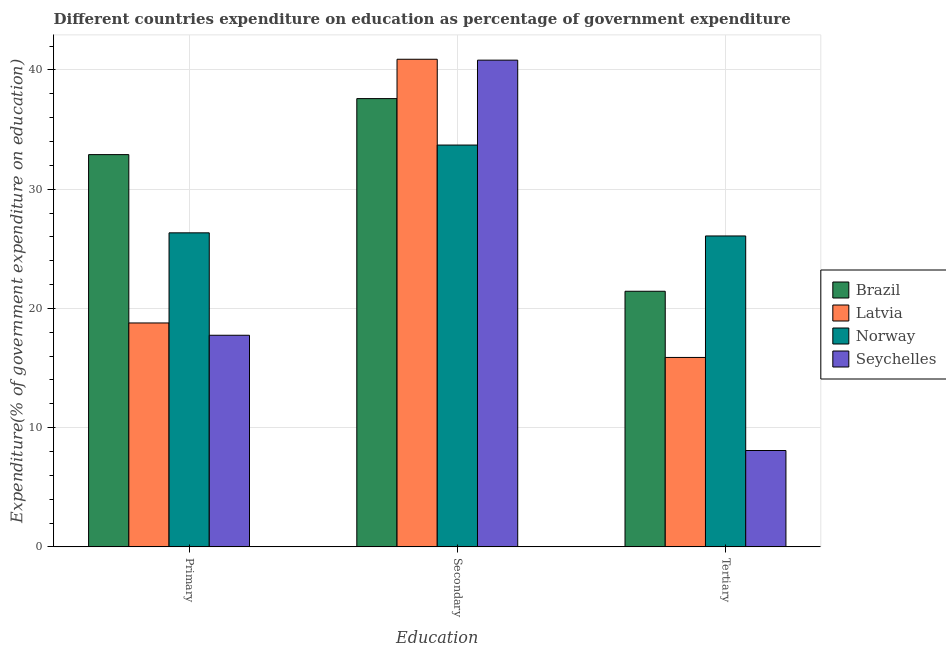How many different coloured bars are there?
Keep it short and to the point. 4. How many groups of bars are there?
Offer a very short reply. 3. Are the number of bars per tick equal to the number of legend labels?
Your response must be concise. Yes. Are the number of bars on each tick of the X-axis equal?
Give a very brief answer. Yes. How many bars are there on the 1st tick from the left?
Ensure brevity in your answer.  4. What is the label of the 3rd group of bars from the left?
Ensure brevity in your answer.  Tertiary. What is the expenditure on secondary education in Seychelles?
Provide a short and direct response. 40.82. Across all countries, what is the maximum expenditure on primary education?
Your response must be concise. 32.9. Across all countries, what is the minimum expenditure on tertiary education?
Make the answer very short. 8.08. In which country was the expenditure on tertiary education maximum?
Your answer should be compact. Norway. In which country was the expenditure on secondary education minimum?
Offer a terse response. Norway. What is the total expenditure on secondary education in the graph?
Offer a terse response. 153.01. What is the difference between the expenditure on secondary education in Seychelles and that in Norway?
Your response must be concise. 7.12. What is the difference between the expenditure on tertiary education in Norway and the expenditure on primary education in Seychelles?
Your response must be concise. 8.33. What is the average expenditure on secondary education per country?
Ensure brevity in your answer.  38.25. What is the difference between the expenditure on secondary education and expenditure on primary education in Latvia?
Make the answer very short. 22.12. In how many countries, is the expenditure on tertiary education greater than 16 %?
Provide a short and direct response. 2. What is the ratio of the expenditure on tertiary education in Brazil to that in Latvia?
Ensure brevity in your answer.  1.35. Is the expenditure on secondary education in Norway less than that in Seychelles?
Offer a terse response. Yes. What is the difference between the highest and the second highest expenditure on secondary education?
Provide a succinct answer. 0.07. What is the difference between the highest and the lowest expenditure on tertiary education?
Offer a terse response. 17.99. Is the sum of the expenditure on primary education in Seychelles and Brazil greater than the maximum expenditure on secondary education across all countries?
Your answer should be compact. Yes. What does the 4th bar from the left in Primary represents?
Provide a succinct answer. Seychelles. What does the 1st bar from the right in Tertiary represents?
Your answer should be compact. Seychelles. Is it the case that in every country, the sum of the expenditure on primary education and expenditure on secondary education is greater than the expenditure on tertiary education?
Provide a short and direct response. Yes. What is the difference between two consecutive major ticks on the Y-axis?
Offer a terse response. 10. Where does the legend appear in the graph?
Offer a very short reply. Center right. What is the title of the graph?
Keep it short and to the point. Different countries expenditure on education as percentage of government expenditure. Does "Niger" appear as one of the legend labels in the graph?
Give a very brief answer. No. What is the label or title of the X-axis?
Keep it short and to the point. Education. What is the label or title of the Y-axis?
Keep it short and to the point. Expenditure(% of government expenditure on education). What is the Expenditure(% of government expenditure on education) in Brazil in Primary?
Keep it short and to the point. 32.9. What is the Expenditure(% of government expenditure on education) of Latvia in Primary?
Make the answer very short. 18.78. What is the Expenditure(% of government expenditure on education) in Norway in Primary?
Your answer should be very brief. 26.34. What is the Expenditure(% of government expenditure on education) of Seychelles in Primary?
Your answer should be very brief. 17.75. What is the Expenditure(% of government expenditure on education) in Brazil in Secondary?
Offer a terse response. 37.6. What is the Expenditure(% of government expenditure on education) of Latvia in Secondary?
Ensure brevity in your answer.  40.9. What is the Expenditure(% of government expenditure on education) of Norway in Secondary?
Offer a very short reply. 33.7. What is the Expenditure(% of government expenditure on education) in Seychelles in Secondary?
Keep it short and to the point. 40.82. What is the Expenditure(% of government expenditure on education) in Brazil in Tertiary?
Offer a terse response. 21.44. What is the Expenditure(% of government expenditure on education) in Latvia in Tertiary?
Offer a very short reply. 15.89. What is the Expenditure(% of government expenditure on education) of Norway in Tertiary?
Provide a succinct answer. 26.07. What is the Expenditure(% of government expenditure on education) in Seychelles in Tertiary?
Offer a very short reply. 8.08. Across all Education, what is the maximum Expenditure(% of government expenditure on education) of Brazil?
Provide a short and direct response. 37.6. Across all Education, what is the maximum Expenditure(% of government expenditure on education) of Latvia?
Give a very brief answer. 40.9. Across all Education, what is the maximum Expenditure(% of government expenditure on education) of Norway?
Your answer should be very brief. 33.7. Across all Education, what is the maximum Expenditure(% of government expenditure on education) in Seychelles?
Offer a very short reply. 40.82. Across all Education, what is the minimum Expenditure(% of government expenditure on education) of Brazil?
Offer a terse response. 21.44. Across all Education, what is the minimum Expenditure(% of government expenditure on education) of Latvia?
Your response must be concise. 15.89. Across all Education, what is the minimum Expenditure(% of government expenditure on education) of Norway?
Offer a very short reply. 26.07. Across all Education, what is the minimum Expenditure(% of government expenditure on education) of Seychelles?
Provide a short and direct response. 8.08. What is the total Expenditure(% of government expenditure on education) of Brazil in the graph?
Provide a succinct answer. 91.93. What is the total Expenditure(% of government expenditure on education) of Latvia in the graph?
Ensure brevity in your answer.  75.56. What is the total Expenditure(% of government expenditure on education) in Norway in the graph?
Provide a succinct answer. 86.11. What is the total Expenditure(% of government expenditure on education) of Seychelles in the graph?
Your answer should be compact. 66.65. What is the difference between the Expenditure(% of government expenditure on education) in Brazil in Primary and that in Secondary?
Your response must be concise. -4.7. What is the difference between the Expenditure(% of government expenditure on education) of Latvia in Primary and that in Secondary?
Your response must be concise. -22.12. What is the difference between the Expenditure(% of government expenditure on education) of Norway in Primary and that in Secondary?
Provide a short and direct response. -7.36. What is the difference between the Expenditure(% of government expenditure on education) of Seychelles in Primary and that in Secondary?
Ensure brevity in your answer.  -23.07. What is the difference between the Expenditure(% of government expenditure on education) in Brazil in Primary and that in Tertiary?
Offer a very short reply. 11.46. What is the difference between the Expenditure(% of government expenditure on education) in Latvia in Primary and that in Tertiary?
Your answer should be very brief. 2.89. What is the difference between the Expenditure(% of government expenditure on education) in Norway in Primary and that in Tertiary?
Give a very brief answer. 0.26. What is the difference between the Expenditure(% of government expenditure on education) of Seychelles in Primary and that in Tertiary?
Your answer should be compact. 9.67. What is the difference between the Expenditure(% of government expenditure on education) in Brazil in Secondary and that in Tertiary?
Make the answer very short. 16.16. What is the difference between the Expenditure(% of government expenditure on education) of Latvia in Secondary and that in Tertiary?
Ensure brevity in your answer.  25.01. What is the difference between the Expenditure(% of government expenditure on education) of Norway in Secondary and that in Tertiary?
Your answer should be very brief. 7.63. What is the difference between the Expenditure(% of government expenditure on education) of Seychelles in Secondary and that in Tertiary?
Your response must be concise. 32.74. What is the difference between the Expenditure(% of government expenditure on education) of Brazil in Primary and the Expenditure(% of government expenditure on education) of Latvia in Secondary?
Ensure brevity in your answer.  -8. What is the difference between the Expenditure(% of government expenditure on education) of Brazil in Primary and the Expenditure(% of government expenditure on education) of Norway in Secondary?
Provide a short and direct response. -0.8. What is the difference between the Expenditure(% of government expenditure on education) in Brazil in Primary and the Expenditure(% of government expenditure on education) in Seychelles in Secondary?
Provide a succinct answer. -7.92. What is the difference between the Expenditure(% of government expenditure on education) of Latvia in Primary and the Expenditure(% of government expenditure on education) of Norway in Secondary?
Make the answer very short. -14.92. What is the difference between the Expenditure(% of government expenditure on education) in Latvia in Primary and the Expenditure(% of government expenditure on education) in Seychelles in Secondary?
Keep it short and to the point. -22.04. What is the difference between the Expenditure(% of government expenditure on education) of Norway in Primary and the Expenditure(% of government expenditure on education) of Seychelles in Secondary?
Provide a succinct answer. -14.48. What is the difference between the Expenditure(% of government expenditure on education) in Brazil in Primary and the Expenditure(% of government expenditure on education) in Latvia in Tertiary?
Your answer should be compact. 17.01. What is the difference between the Expenditure(% of government expenditure on education) in Brazil in Primary and the Expenditure(% of government expenditure on education) in Norway in Tertiary?
Your response must be concise. 6.82. What is the difference between the Expenditure(% of government expenditure on education) of Brazil in Primary and the Expenditure(% of government expenditure on education) of Seychelles in Tertiary?
Ensure brevity in your answer.  24.82. What is the difference between the Expenditure(% of government expenditure on education) in Latvia in Primary and the Expenditure(% of government expenditure on education) in Norway in Tertiary?
Offer a terse response. -7.3. What is the difference between the Expenditure(% of government expenditure on education) of Latvia in Primary and the Expenditure(% of government expenditure on education) of Seychelles in Tertiary?
Offer a terse response. 10.7. What is the difference between the Expenditure(% of government expenditure on education) in Norway in Primary and the Expenditure(% of government expenditure on education) in Seychelles in Tertiary?
Offer a terse response. 18.26. What is the difference between the Expenditure(% of government expenditure on education) in Brazil in Secondary and the Expenditure(% of government expenditure on education) in Latvia in Tertiary?
Keep it short and to the point. 21.71. What is the difference between the Expenditure(% of government expenditure on education) of Brazil in Secondary and the Expenditure(% of government expenditure on education) of Norway in Tertiary?
Your answer should be compact. 11.52. What is the difference between the Expenditure(% of government expenditure on education) of Brazil in Secondary and the Expenditure(% of government expenditure on education) of Seychelles in Tertiary?
Your answer should be compact. 29.52. What is the difference between the Expenditure(% of government expenditure on education) of Latvia in Secondary and the Expenditure(% of government expenditure on education) of Norway in Tertiary?
Make the answer very short. 14.82. What is the difference between the Expenditure(% of government expenditure on education) of Latvia in Secondary and the Expenditure(% of government expenditure on education) of Seychelles in Tertiary?
Your response must be concise. 32.82. What is the difference between the Expenditure(% of government expenditure on education) of Norway in Secondary and the Expenditure(% of government expenditure on education) of Seychelles in Tertiary?
Your answer should be compact. 25.62. What is the average Expenditure(% of government expenditure on education) of Brazil per Education?
Your answer should be very brief. 30.64. What is the average Expenditure(% of government expenditure on education) of Latvia per Education?
Offer a very short reply. 25.19. What is the average Expenditure(% of government expenditure on education) of Norway per Education?
Your answer should be very brief. 28.7. What is the average Expenditure(% of government expenditure on education) of Seychelles per Education?
Ensure brevity in your answer.  22.22. What is the difference between the Expenditure(% of government expenditure on education) in Brazil and Expenditure(% of government expenditure on education) in Latvia in Primary?
Provide a short and direct response. 14.12. What is the difference between the Expenditure(% of government expenditure on education) in Brazil and Expenditure(% of government expenditure on education) in Norway in Primary?
Give a very brief answer. 6.56. What is the difference between the Expenditure(% of government expenditure on education) in Brazil and Expenditure(% of government expenditure on education) in Seychelles in Primary?
Your answer should be very brief. 15.15. What is the difference between the Expenditure(% of government expenditure on education) in Latvia and Expenditure(% of government expenditure on education) in Norway in Primary?
Give a very brief answer. -7.56. What is the difference between the Expenditure(% of government expenditure on education) of Latvia and Expenditure(% of government expenditure on education) of Seychelles in Primary?
Provide a succinct answer. 1.03. What is the difference between the Expenditure(% of government expenditure on education) of Norway and Expenditure(% of government expenditure on education) of Seychelles in Primary?
Keep it short and to the point. 8.59. What is the difference between the Expenditure(% of government expenditure on education) of Brazil and Expenditure(% of government expenditure on education) of Latvia in Secondary?
Provide a succinct answer. -3.3. What is the difference between the Expenditure(% of government expenditure on education) of Brazil and Expenditure(% of government expenditure on education) of Norway in Secondary?
Ensure brevity in your answer.  3.9. What is the difference between the Expenditure(% of government expenditure on education) of Brazil and Expenditure(% of government expenditure on education) of Seychelles in Secondary?
Ensure brevity in your answer.  -3.22. What is the difference between the Expenditure(% of government expenditure on education) in Latvia and Expenditure(% of government expenditure on education) in Norway in Secondary?
Provide a succinct answer. 7.2. What is the difference between the Expenditure(% of government expenditure on education) in Latvia and Expenditure(% of government expenditure on education) in Seychelles in Secondary?
Ensure brevity in your answer.  0.07. What is the difference between the Expenditure(% of government expenditure on education) in Norway and Expenditure(% of government expenditure on education) in Seychelles in Secondary?
Give a very brief answer. -7.12. What is the difference between the Expenditure(% of government expenditure on education) of Brazil and Expenditure(% of government expenditure on education) of Latvia in Tertiary?
Offer a terse response. 5.55. What is the difference between the Expenditure(% of government expenditure on education) in Brazil and Expenditure(% of government expenditure on education) in Norway in Tertiary?
Offer a very short reply. -4.64. What is the difference between the Expenditure(% of government expenditure on education) in Brazil and Expenditure(% of government expenditure on education) in Seychelles in Tertiary?
Make the answer very short. 13.36. What is the difference between the Expenditure(% of government expenditure on education) of Latvia and Expenditure(% of government expenditure on education) of Norway in Tertiary?
Your response must be concise. -10.19. What is the difference between the Expenditure(% of government expenditure on education) in Latvia and Expenditure(% of government expenditure on education) in Seychelles in Tertiary?
Your response must be concise. 7.81. What is the difference between the Expenditure(% of government expenditure on education) in Norway and Expenditure(% of government expenditure on education) in Seychelles in Tertiary?
Ensure brevity in your answer.  17.99. What is the ratio of the Expenditure(% of government expenditure on education) in Latvia in Primary to that in Secondary?
Offer a terse response. 0.46. What is the ratio of the Expenditure(% of government expenditure on education) in Norway in Primary to that in Secondary?
Offer a very short reply. 0.78. What is the ratio of the Expenditure(% of government expenditure on education) of Seychelles in Primary to that in Secondary?
Offer a very short reply. 0.43. What is the ratio of the Expenditure(% of government expenditure on education) in Brazil in Primary to that in Tertiary?
Your answer should be compact. 1.53. What is the ratio of the Expenditure(% of government expenditure on education) in Latvia in Primary to that in Tertiary?
Your answer should be compact. 1.18. What is the ratio of the Expenditure(% of government expenditure on education) in Norway in Primary to that in Tertiary?
Make the answer very short. 1.01. What is the ratio of the Expenditure(% of government expenditure on education) in Seychelles in Primary to that in Tertiary?
Provide a succinct answer. 2.2. What is the ratio of the Expenditure(% of government expenditure on education) of Brazil in Secondary to that in Tertiary?
Provide a short and direct response. 1.75. What is the ratio of the Expenditure(% of government expenditure on education) in Latvia in Secondary to that in Tertiary?
Keep it short and to the point. 2.57. What is the ratio of the Expenditure(% of government expenditure on education) of Norway in Secondary to that in Tertiary?
Make the answer very short. 1.29. What is the ratio of the Expenditure(% of government expenditure on education) of Seychelles in Secondary to that in Tertiary?
Provide a short and direct response. 5.05. What is the difference between the highest and the second highest Expenditure(% of government expenditure on education) of Brazil?
Provide a short and direct response. 4.7. What is the difference between the highest and the second highest Expenditure(% of government expenditure on education) in Latvia?
Offer a very short reply. 22.12. What is the difference between the highest and the second highest Expenditure(% of government expenditure on education) of Norway?
Keep it short and to the point. 7.36. What is the difference between the highest and the second highest Expenditure(% of government expenditure on education) in Seychelles?
Your answer should be compact. 23.07. What is the difference between the highest and the lowest Expenditure(% of government expenditure on education) of Brazil?
Keep it short and to the point. 16.16. What is the difference between the highest and the lowest Expenditure(% of government expenditure on education) in Latvia?
Offer a terse response. 25.01. What is the difference between the highest and the lowest Expenditure(% of government expenditure on education) of Norway?
Ensure brevity in your answer.  7.63. What is the difference between the highest and the lowest Expenditure(% of government expenditure on education) of Seychelles?
Your response must be concise. 32.74. 